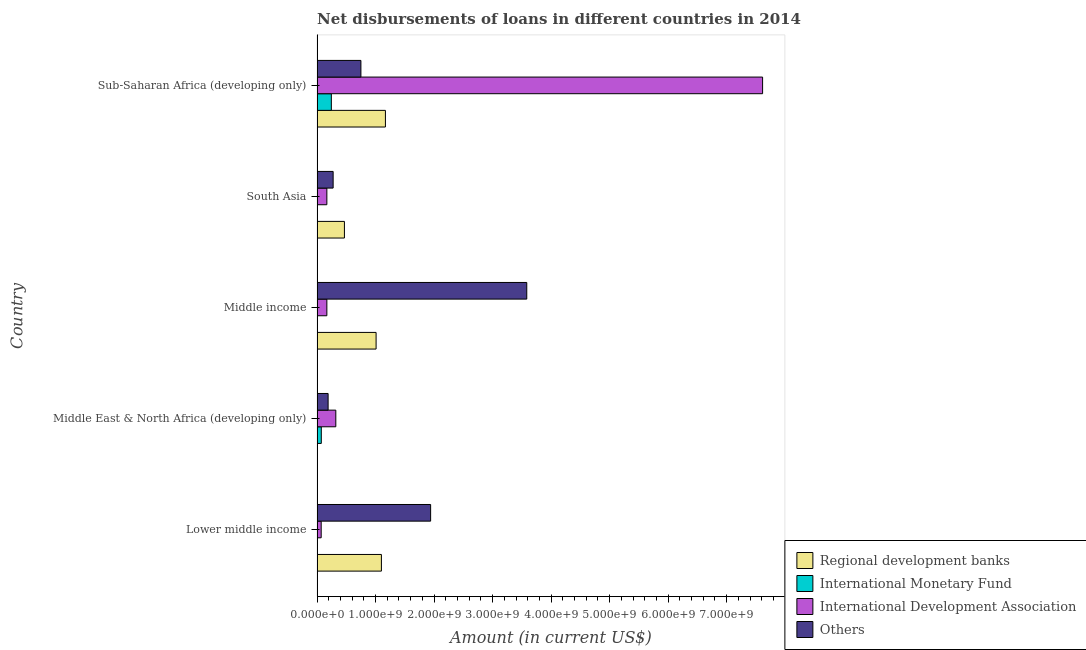Are the number of bars on each tick of the Y-axis equal?
Make the answer very short. No. What is the label of the 5th group of bars from the top?
Your answer should be very brief. Lower middle income. Across all countries, what is the maximum amount of loan disimbursed by international monetary fund?
Your response must be concise. 2.44e+08. Across all countries, what is the minimum amount of loan disimbursed by regional development banks?
Your response must be concise. 0. In which country was the amount of loan disimbursed by regional development banks maximum?
Keep it short and to the point. Sub-Saharan Africa (developing only). What is the total amount of loan disimbursed by international monetary fund in the graph?
Your answer should be compact. 3.17e+08. What is the difference between the amount of loan disimbursed by international development association in Lower middle income and that in Middle income?
Keep it short and to the point. -9.71e+07. What is the difference between the amount of loan disimbursed by international development association in South Asia and the amount of loan disimbursed by regional development banks in Middle income?
Make the answer very short. -8.41e+08. What is the average amount of loan disimbursed by other organisations per country?
Your response must be concise. 1.35e+09. What is the difference between the amount of loan disimbursed by international development association and amount of loan disimbursed by regional development banks in Middle income?
Ensure brevity in your answer.  -8.41e+08. What is the ratio of the amount of loan disimbursed by international development association in Lower middle income to that in Sub-Saharan Africa (developing only)?
Provide a short and direct response. 0.01. Is the amount of loan disimbursed by regional development banks in Lower middle income less than that in South Asia?
Give a very brief answer. No. What is the difference between the highest and the second highest amount of loan disimbursed by international development association?
Your response must be concise. 7.29e+09. What is the difference between the highest and the lowest amount of loan disimbursed by international development association?
Provide a succinct answer. 7.54e+09. Is the sum of the amount of loan disimbursed by international development association in Middle income and South Asia greater than the maximum amount of loan disimbursed by regional development banks across all countries?
Your answer should be compact. No. Is it the case that in every country, the sum of the amount of loan disimbursed by regional development banks and amount of loan disimbursed by international monetary fund is greater than the amount of loan disimbursed by international development association?
Offer a very short reply. No. How many bars are there?
Ensure brevity in your answer.  16. How many countries are there in the graph?
Your answer should be very brief. 5. What is the difference between two consecutive major ticks on the X-axis?
Your response must be concise. 1.00e+09. Are the values on the major ticks of X-axis written in scientific E-notation?
Provide a short and direct response. Yes. Where does the legend appear in the graph?
Ensure brevity in your answer.  Bottom right. What is the title of the graph?
Your answer should be compact. Net disbursements of loans in different countries in 2014. What is the Amount (in current US$) in Regional development banks in Lower middle income?
Offer a very short reply. 1.10e+09. What is the Amount (in current US$) in International Monetary Fund in Lower middle income?
Offer a very short reply. 0. What is the Amount (in current US$) in International Development Association in Lower middle income?
Offer a terse response. 7.06e+07. What is the Amount (in current US$) in Others in Lower middle income?
Make the answer very short. 1.94e+09. What is the Amount (in current US$) of International Monetary Fund in Middle East & North Africa (developing only)?
Provide a succinct answer. 7.27e+07. What is the Amount (in current US$) of International Development Association in Middle East & North Africa (developing only)?
Provide a short and direct response. 3.20e+08. What is the Amount (in current US$) in Others in Middle East & North Africa (developing only)?
Give a very brief answer. 1.89e+08. What is the Amount (in current US$) in Regional development banks in Middle income?
Keep it short and to the point. 1.01e+09. What is the Amount (in current US$) in International Development Association in Middle income?
Ensure brevity in your answer.  1.68e+08. What is the Amount (in current US$) of Others in Middle income?
Ensure brevity in your answer.  3.58e+09. What is the Amount (in current US$) of Regional development banks in South Asia?
Provide a succinct answer. 4.68e+08. What is the Amount (in current US$) in International Monetary Fund in South Asia?
Offer a terse response. 0. What is the Amount (in current US$) in International Development Association in South Asia?
Your answer should be very brief. 1.68e+08. What is the Amount (in current US$) in Others in South Asia?
Provide a short and direct response. 2.75e+08. What is the Amount (in current US$) in Regional development banks in Sub-Saharan Africa (developing only)?
Your answer should be compact. 1.17e+09. What is the Amount (in current US$) of International Monetary Fund in Sub-Saharan Africa (developing only)?
Give a very brief answer. 2.44e+08. What is the Amount (in current US$) in International Development Association in Sub-Saharan Africa (developing only)?
Make the answer very short. 7.61e+09. What is the Amount (in current US$) of Others in Sub-Saharan Africa (developing only)?
Keep it short and to the point. 7.49e+08. Across all countries, what is the maximum Amount (in current US$) in Regional development banks?
Your answer should be very brief. 1.17e+09. Across all countries, what is the maximum Amount (in current US$) in International Monetary Fund?
Offer a very short reply. 2.44e+08. Across all countries, what is the maximum Amount (in current US$) of International Development Association?
Your answer should be very brief. 7.61e+09. Across all countries, what is the maximum Amount (in current US$) in Others?
Provide a short and direct response. 3.58e+09. Across all countries, what is the minimum Amount (in current US$) of Regional development banks?
Your answer should be very brief. 0. Across all countries, what is the minimum Amount (in current US$) in International Development Association?
Make the answer very short. 7.06e+07. Across all countries, what is the minimum Amount (in current US$) of Others?
Your response must be concise. 1.89e+08. What is the total Amount (in current US$) in Regional development banks in the graph?
Offer a very short reply. 3.74e+09. What is the total Amount (in current US$) of International Monetary Fund in the graph?
Offer a very short reply. 3.17e+08. What is the total Amount (in current US$) in International Development Association in the graph?
Make the answer very short. 8.34e+09. What is the total Amount (in current US$) in Others in the graph?
Keep it short and to the point. 6.74e+09. What is the difference between the Amount (in current US$) of International Development Association in Lower middle income and that in Middle East & North Africa (developing only)?
Offer a terse response. -2.50e+08. What is the difference between the Amount (in current US$) in Others in Lower middle income and that in Middle East & North Africa (developing only)?
Provide a short and direct response. 1.75e+09. What is the difference between the Amount (in current US$) in Regional development banks in Lower middle income and that in Middle income?
Provide a succinct answer. 9.09e+07. What is the difference between the Amount (in current US$) in International Development Association in Lower middle income and that in Middle income?
Offer a very short reply. -9.71e+07. What is the difference between the Amount (in current US$) of Others in Lower middle income and that in Middle income?
Provide a short and direct response. -1.64e+09. What is the difference between the Amount (in current US$) of Regional development banks in Lower middle income and that in South Asia?
Provide a short and direct response. 6.32e+08. What is the difference between the Amount (in current US$) of International Development Association in Lower middle income and that in South Asia?
Provide a succinct answer. -9.71e+07. What is the difference between the Amount (in current US$) of Others in Lower middle income and that in South Asia?
Provide a short and direct response. 1.67e+09. What is the difference between the Amount (in current US$) of Regional development banks in Lower middle income and that in Sub-Saharan Africa (developing only)?
Offer a terse response. -6.87e+07. What is the difference between the Amount (in current US$) in International Development Association in Lower middle income and that in Sub-Saharan Africa (developing only)?
Offer a very short reply. -7.54e+09. What is the difference between the Amount (in current US$) of Others in Lower middle income and that in Sub-Saharan Africa (developing only)?
Give a very brief answer. 1.19e+09. What is the difference between the Amount (in current US$) of International Development Association in Middle East & North Africa (developing only) and that in Middle income?
Your response must be concise. 1.53e+08. What is the difference between the Amount (in current US$) of Others in Middle East & North Africa (developing only) and that in Middle income?
Keep it short and to the point. -3.39e+09. What is the difference between the Amount (in current US$) of International Development Association in Middle East & North Africa (developing only) and that in South Asia?
Offer a very short reply. 1.53e+08. What is the difference between the Amount (in current US$) in Others in Middle East & North Africa (developing only) and that in South Asia?
Provide a short and direct response. -8.59e+07. What is the difference between the Amount (in current US$) of International Monetary Fund in Middle East & North Africa (developing only) and that in Sub-Saharan Africa (developing only)?
Your answer should be compact. -1.71e+08. What is the difference between the Amount (in current US$) in International Development Association in Middle East & North Africa (developing only) and that in Sub-Saharan Africa (developing only)?
Give a very brief answer. -7.29e+09. What is the difference between the Amount (in current US$) in Others in Middle East & North Africa (developing only) and that in Sub-Saharan Africa (developing only)?
Your answer should be very brief. -5.60e+08. What is the difference between the Amount (in current US$) in Regional development banks in Middle income and that in South Asia?
Offer a terse response. 5.41e+08. What is the difference between the Amount (in current US$) in International Development Association in Middle income and that in South Asia?
Offer a terse response. 0. What is the difference between the Amount (in current US$) in Others in Middle income and that in South Asia?
Provide a succinct answer. 3.31e+09. What is the difference between the Amount (in current US$) in Regional development banks in Middle income and that in Sub-Saharan Africa (developing only)?
Offer a very short reply. -1.60e+08. What is the difference between the Amount (in current US$) in International Development Association in Middle income and that in Sub-Saharan Africa (developing only)?
Ensure brevity in your answer.  -7.45e+09. What is the difference between the Amount (in current US$) of Others in Middle income and that in Sub-Saharan Africa (developing only)?
Your answer should be very brief. 2.83e+09. What is the difference between the Amount (in current US$) in Regional development banks in South Asia and that in Sub-Saharan Africa (developing only)?
Your answer should be very brief. -7.01e+08. What is the difference between the Amount (in current US$) of International Development Association in South Asia and that in Sub-Saharan Africa (developing only)?
Give a very brief answer. -7.45e+09. What is the difference between the Amount (in current US$) in Others in South Asia and that in Sub-Saharan Africa (developing only)?
Offer a very short reply. -4.75e+08. What is the difference between the Amount (in current US$) of Regional development banks in Lower middle income and the Amount (in current US$) of International Monetary Fund in Middle East & North Africa (developing only)?
Your answer should be compact. 1.03e+09. What is the difference between the Amount (in current US$) in Regional development banks in Lower middle income and the Amount (in current US$) in International Development Association in Middle East & North Africa (developing only)?
Your response must be concise. 7.79e+08. What is the difference between the Amount (in current US$) in Regional development banks in Lower middle income and the Amount (in current US$) in Others in Middle East & North Africa (developing only)?
Offer a terse response. 9.11e+08. What is the difference between the Amount (in current US$) of International Development Association in Lower middle income and the Amount (in current US$) of Others in Middle East & North Africa (developing only)?
Ensure brevity in your answer.  -1.18e+08. What is the difference between the Amount (in current US$) in Regional development banks in Lower middle income and the Amount (in current US$) in International Development Association in Middle income?
Your answer should be compact. 9.32e+08. What is the difference between the Amount (in current US$) in Regional development banks in Lower middle income and the Amount (in current US$) in Others in Middle income?
Your answer should be very brief. -2.48e+09. What is the difference between the Amount (in current US$) in International Development Association in Lower middle income and the Amount (in current US$) in Others in Middle income?
Keep it short and to the point. -3.51e+09. What is the difference between the Amount (in current US$) in Regional development banks in Lower middle income and the Amount (in current US$) in International Development Association in South Asia?
Offer a terse response. 9.32e+08. What is the difference between the Amount (in current US$) in Regional development banks in Lower middle income and the Amount (in current US$) in Others in South Asia?
Provide a short and direct response. 8.25e+08. What is the difference between the Amount (in current US$) of International Development Association in Lower middle income and the Amount (in current US$) of Others in South Asia?
Ensure brevity in your answer.  -2.04e+08. What is the difference between the Amount (in current US$) of Regional development banks in Lower middle income and the Amount (in current US$) of International Monetary Fund in Sub-Saharan Africa (developing only)?
Your answer should be compact. 8.56e+08. What is the difference between the Amount (in current US$) in Regional development banks in Lower middle income and the Amount (in current US$) in International Development Association in Sub-Saharan Africa (developing only)?
Offer a very short reply. -6.51e+09. What is the difference between the Amount (in current US$) of Regional development banks in Lower middle income and the Amount (in current US$) of Others in Sub-Saharan Africa (developing only)?
Provide a short and direct response. 3.50e+08. What is the difference between the Amount (in current US$) of International Development Association in Lower middle income and the Amount (in current US$) of Others in Sub-Saharan Africa (developing only)?
Keep it short and to the point. -6.79e+08. What is the difference between the Amount (in current US$) of International Monetary Fund in Middle East & North Africa (developing only) and the Amount (in current US$) of International Development Association in Middle income?
Your answer should be compact. -9.50e+07. What is the difference between the Amount (in current US$) of International Monetary Fund in Middle East & North Africa (developing only) and the Amount (in current US$) of Others in Middle income?
Offer a terse response. -3.51e+09. What is the difference between the Amount (in current US$) of International Development Association in Middle East & North Africa (developing only) and the Amount (in current US$) of Others in Middle income?
Provide a short and direct response. -3.26e+09. What is the difference between the Amount (in current US$) of International Monetary Fund in Middle East & North Africa (developing only) and the Amount (in current US$) of International Development Association in South Asia?
Your answer should be very brief. -9.50e+07. What is the difference between the Amount (in current US$) of International Monetary Fund in Middle East & North Africa (developing only) and the Amount (in current US$) of Others in South Asia?
Offer a terse response. -2.02e+08. What is the difference between the Amount (in current US$) of International Development Association in Middle East & North Africa (developing only) and the Amount (in current US$) of Others in South Asia?
Keep it short and to the point. 4.56e+07. What is the difference between the Amount (in current US$) in International Monetary Fund in Middle East & North Africa (developing only) and the Amount (in current US$) in International Development Association in Sub-Saharan Africa (developing only)?
Make the answer very short. -7.54e+09. What is the difference between the Amount (in current US$) in International Monetary Fund in Middle East & North Africa (developing only) and the Amount (in current US$) in Others in Sub-Saharan Africa (developing only)?
Ensure brevity in your answer.  -6.77e+08. What is the difference between the Amount (in current US$) of International Development Association in Middle East & North Africa (developing only) and the Amount (in current US$) of Others in Sub-Saharan Africa (developing only)?
Ensure brevity in your answer.  -4.29e+08. What is the difference between the Amount (in current US$) in Regional development banks in Middle income and the Amount (in current US$) in International Development Association in South Asia?
Give a very brief answer. 8.41e+08. What is the difference between the Amount (in current US$) of Regional development banks in Middle income and the Amount (in current US$) of Others in South Asia?
Give a very brief answer. 7.34e+08. What is the difference between the Amount (in current US$) of International Development Association in Middle income and the Amount (in current US$) of Others in South Asia?
Offer a terse response. -1.07e+08. What is the difference between the Amount (in current US$) of Regional development banks in Middle income and the Amount (in current US$) of International Monetary Fund in Sub-Saharan Africa (developing only)?
Your answer should be compact. 7.65e+08. What is the difference between the Amount (in current US$) of Regional development banks in Middle income and the Amount (in current US$) of International Development Association in Sub-Saharan Africa (developing only)?
Make the answer very short. -6.60e+09. What is the difference between the Amount (in current US$) in Regional development banks in Middle income and the Amount (in current US$) in Others in Sub-Saharan Africa (developing only)?
Provide a succinct answer. 2.59e+08. What is the difference between the Amount (in current US$) in International Development Association in Middle income and the Amount (in current US$) in Others in Sub-Saharan Africa (developing only)?
Provide a succinct answer. -5.82e+08. What is the difference between the Amount (in current US$) in Regional development banks in South Asia and the Amount (in current US$) in International Monetary Fund in Sub-Saharan Africa (developing only)?
Give a very brief answer. 2.24e+08. What is the difference between the Amount (in current US$) of Regional development banks in South Asia and the Amount (in current US$) of International Development Association in Sub-Saharan Africa (developing only)?
Offer a terse response. -7.15e+09. What is the difference between the Amount (in current US$) in Regional development banks in South Asia and the Amount (in current US$) in Others in Sub-Saharan Africa (developing only)?
Keep it short and to the point. -2.82e+08. What is the difference between the Amount (in current US$) of International Development Association in South Asia and the Amount (in current US$) of Others in Sub-Saharan Africa (developing only)?
Provide a succinct answer. -5.82e+08. What is the average Amount (in current US$) in Regional development banks per country?
Give a very brief answer. 7.49e+08. What is the average Amount (in current US$) of International Monetary Fund per country?
Keep it short and to the point. 6.34e+07. What is the average Amount (in current US$) of International Development Association per country?
Provide a short and direct response. 1.67e+09. What is the average Amount (in current US$) of Others per country?
Give a very brief answer. 1.35e+09. What is the difference between the Amount (in current US$) of Regional development banks and Amount (in current US$) of International Development Association in Lower middle income?
Provide a succinct answer. 1.03e+09. What is the difference between the Amount (in current US$) in Regional development banks and Amount (in current US$) in Others in Lower middle income?
Give a very brief answer. -8.41e+08. What is the difference between the Amount (in current US$) of International Development Association and Amount (in current US$) of Others in Lower middle income?
Your answer should be very brief. -1.87e+09. What is the difference between the Amount (in current US$) of International Monetary Fund and Amount (in current US$) of International Development Association in Middle East & North Africa (developing only)?
Offer a very short reply. -2.48e+08. What is the difference between the Amount (in current US$) of International Monetary Fund and Amount (in current US$) of Others in Middle East & North Africa (developing only)?
Provide a short and direct response. -1.16e+08. What is the difference between the Amount (in current US$) of International Development Association and Amount (in current US$) of Others in Middle East & North Africa (developing only)?
Make the answer very short. 1.32e+08. What is the difference between the Amount (in current US$) in Regional development banks and Amount (in current US$) in International Development Association in Middle income?
Your response must be concise. 8.41e+08. What is the difference between the Amount (in current US$) of Regional development banks and Amount (in current US$) of Others in Middle income?
Your response must be concise. -2.58e+09. What is the difference between the Amount (in current US$) in International Development Association and Amount (in current US$) in Others in Middle income?
Provide a succinct answer. -3.42e+09. What is the difference between the Amount (in current US$) of Regional development banks and Amount (in current US$) of International Development Association in South Asia?
Provide a short and direct response. 3.00e+08. What is the difference between the Amount (in current US$) of Regional development banks and Amount (in current US$) of Others in South Asia?
Offer a very short reply. 1.93e+08. What is the difference between the Amount (in current US$) in International Development Association and Amount (in current US$) in Others in South Asia?
Offer a terse response. -1.07e+08. What is the difference between the Amount (in current US$) in Regional development banks and Amount (in current US$) in International Monetary Fund in Sub-Saharan Africa (developing only)?
Your answer should be very brief. 9.24e+08. What is the difference between the Amount (in current US$) of Regional development banks and Amount (in current US$) of International Development Association in Sub-Saharan Africa (developing only)?
Provide a succinct answer. -6.45e+09. What is the difference between the Amount (in current US$) of Regional development banks and Amount (in current US$) of Others in Sub-Saharan Africa (developing only)?
Keep it short and to the point. 4.19e+08. What is the difference between the Amount (in current US$) of International Monetary Fund and Amount (in current US$) of International Development Association in Sub-Saharan Africa (developing only)?
Give a very brief answer. -7.37e+09. What is the difference between the Amount (in current US$) in International Monetary Fund and Amount (in current US$) in Others in Sub-Saharan Africa (developing only)?
Keep it short and to the point. -5.05e+08. What is the difference between the Amount (in current US$) in International Development Association and Amount (in current US$) in Others in Sub-Saharan Africa (developing only)?
Your response must be concise. 6.86e+09. What is the ratio of the Amount (in current US$) of International Development Association in Lower middle income to that in Middle East & North Africa (developing only)?
Your response must be concise. 0.22. What is the ratio of the Amount (in current US$) of Others in Lower middle income to that in Middle East & North Africa (developing only)?
Offer a very short reply. 10.27. What is the ratio of the Amount (in current US$) of Regional development banks in Lower middle income to that in Middle income?
Offer a very short reply. 1.09. What is the ratio of the Amount (in current US$) in International Development Association in Lower middle income to that in Middle income?
Provide a succinct answer. 0.42. What is the ratio of the Amount (in current US$) of Others in Lower middle income to that in Middle income?
Provide a short and direct response. 0.54. What is the ratio of the Amount (in current US$) of Regional development banks in Lower middle income to that in South Asia?
Offer a very short reply. 2.35. What is the ratio of the Amount (in current US$) in International Development Association in Lower middle income to that in South Asia?
Give a very brief answer. 0.42. What is the ratio of the Amount (in current US$) in Others in Lower middle income to that in South Asia?
Provide a short and direct response. 7.06. What is the ratio of the Amount (in current US$) in International Development Association in Lower middle income to that in Sub-Saharan Africa (developing only)?
Provide a succinct answer. 0.01. What is the ratio of the Amount (in current US$) of Others in Lower middle income to that in Sub-Saharan Africa (developing only)?
Provide a short and direct response. 2.59. What is the ratio of the Amount (in current US$) in International Development Association in Middle East & North Africa (developing only) to that in Middle income?
Give a very brief answer. 1.91. What is the ratio of the Amount (in current US$) of Others in Middle East & North Africa (developing only) to that in Middle income?
Your response must be concise. 0.05. What is the ratio of the Amount (in current US$) of International Development Association in Middle East & North Africa (developing only) to that in South Asia?
Give a very brief answer. 1.91. What is the ratio of the Amount (in current US$) of Others in Middle East & North Africa (developing only) to that in South Asia?
Your answer should be very brief. 0.69. What is the ratio of the Amount (in current US$) of International Monetary Fund in Middle East & North Africa (developing only) to that in Sub-Saharan Africa (developing only)?
Make the answer very short. 0.3. What is the ratio of the Amount (in current US$) of International Development Association in Middle East & North Africa (developing only) to that in Sub-Saharan Africa (developing only)?
Your answer should be very brief. 0.04. What is the ratio of the Amount (in current US$) of Others in Middle East & North Africa (developing only) to that in Sub-Saharan Africa (developing only)?
Offer a very short reply. 0.25. What is the ratio of the Amount (in current US$) of Regional development banks in Middle income to that in South Asia?
Offer a terse response. 2.16. What is the ratio of the Amount (in current US$) of Others in Middle income to that in South Asia?
Ensure brevity in your answer.  13.04. What is the ratio of the Amount (in current US$) in Regional development banks in Middle income to that in Sub-Saharan Africa (developing only)?
Your answer should be compact. 0.86. What is the ratio of the Amount (in current US$) of International Development Association in Middle income to that in Sub-Saharan Africa (developing only)?
Give a very brief answer. 0.02. What is the ratio of the Amount (in current US$) of Others in Middle income to that in Sub-Saharan Africa (developing only)?
Your answer should be very brief. 4.78. What is the ratio of the Amount (in current US$) of Regional development banks in South Asia to that in Sub-Saharan Africa (developing only)?
Keep it short and to the point. 0.4. What is the ratio of the Amount (in current US$) in International Development Association in South Asia to that in Sub-Saharan Africa (developing only)?
Your answer should be compact. 0.02. What is the ratio of the Amount (in current US$) of Others in South Asia to that in Sub-Saharan Africa (developing only)?
Your answer should be compact. 0.37. What is the difference between the highest and the second highest Amount (in current US$) in Regional development banks?
Offer a terse response. 6.87e+07. What is the difference between the highest and the second highest Amount (in current US$) of International Development Association?
Offer a terse response. 7.29e+09. What is the difference between the highest and the second highest Amount (in current US$) of Others?
Ensure brevity in your answer.  1.64e+09. What is the difference between the highest and the lowest Amount (in current US$) in Regional development banks?
Give a very brief answer. 1.17e+09. What is the difference between the highest and the lowest Amount (in current US$) of International Monetary Fund?
Your answer should be compact. 2.44e+08. What is the difference between the highest and the lowest Amount (in current US$) in International Development Association?
Keep it short and to the point. 7.54e+09. What is the difference between the highest and the lowest Amount (in current US$) of Others?
Give a very brief answer. 3.39e+09. 